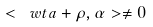Convert formula to latex. <formula><loc_0><loc_0><loc_500><loc_500>< \ w t a + \rho , \alpha > \neq 0</formula> 